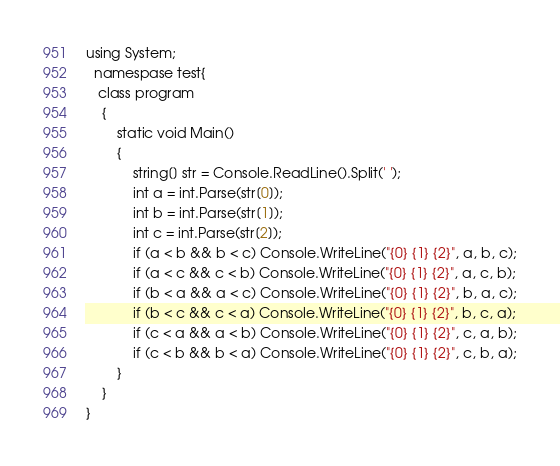Convert code to text. <code><loc_0><loc_0><loc_500><loc_500><_C#_>using System;
  namespase test{
   class program
    {
        static void Main()
        {
            string[] str = Console.ReadLine().Split(' ');
            int a = int.Parse(str[0]);
            int b = int.Parse(str[1]);
            int c = int.Parse(str[2]);
            if (a < b && b < c) Console.WriteLine("{0} {1} {2}", a, b, c);
            if (a < c && c < b) Console.WriteLine("{0} {1} {2}", a, c, b);
            if (b < a && a < c) Console.WriteLine("{0} {1} {2}", b, a, c);
            if (b < c && c < a) Console.WriteLine("{0} {1} {2}", b, c, a);
            if (c < a && a < b) Console.WriteLine("{0} {1} {2}", c, a, b);
            if (c < b && b < a) Console.WriteLine("{0} {1} {2}", c, b, a);
        }
    }
}</code> 